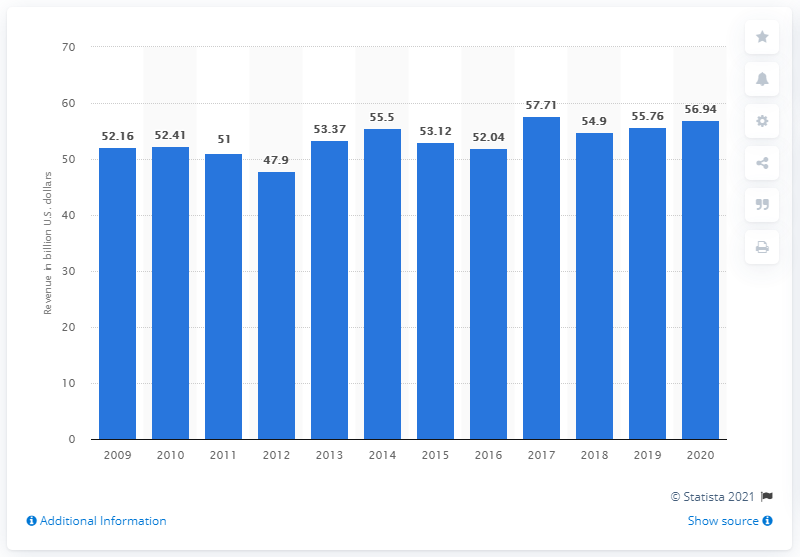Indicate a few pertinent items in this graphic. In 2020, the global revenue of LG Electronics was 56.94 billion U.S. dollars. 